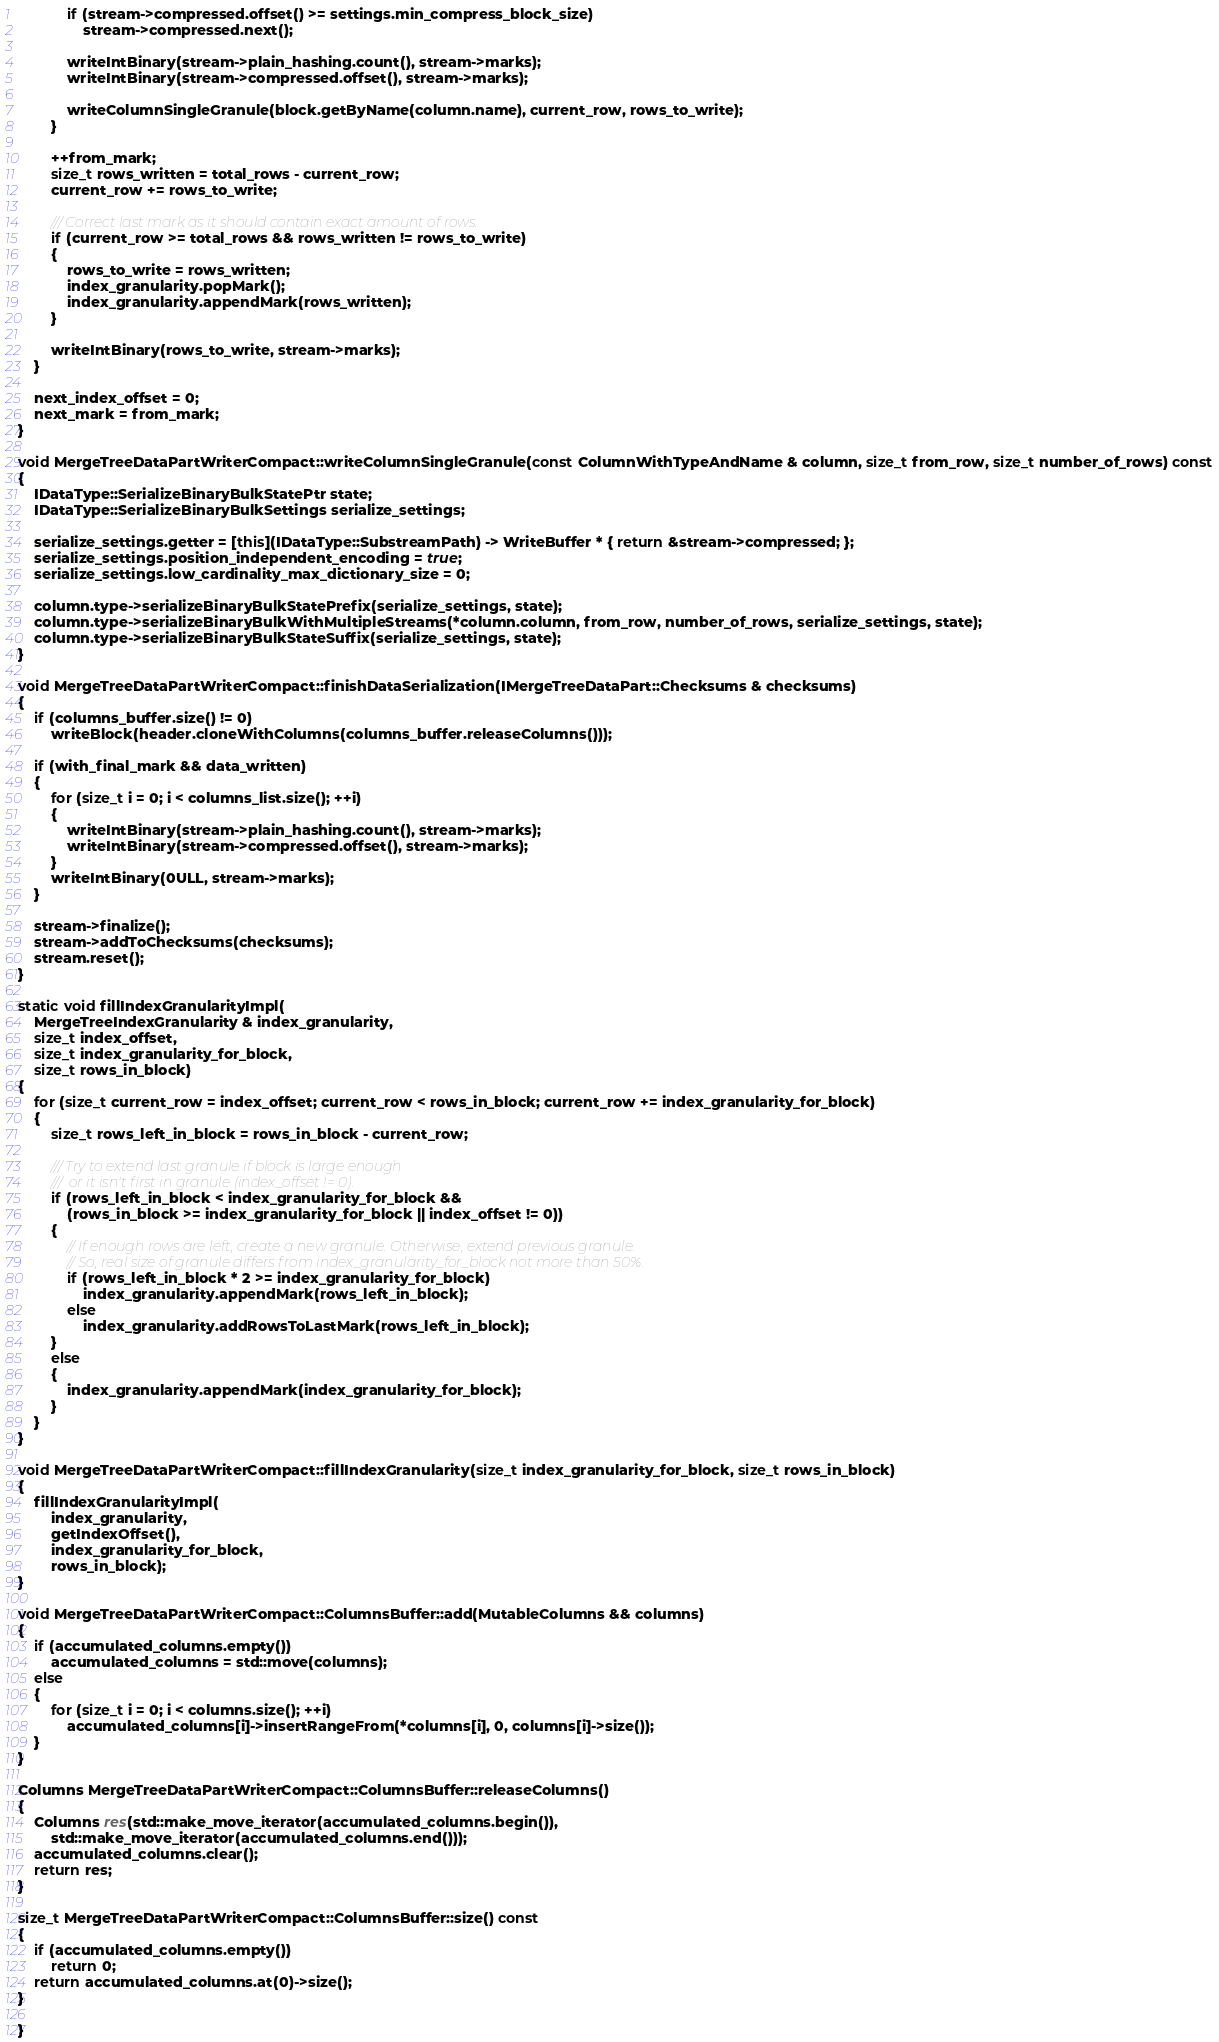<code> <loc_0><loc_0><loc_500><loc_500><_C++_>            if (stream->compressed.offset() >= settings.min_compress_block_size)
                stream->compressed.next();

            writeIntBinary(stream->plain_hashing.count(), stream->marks);
            writeIntBinary(stream->compressed.offset(), stream->marks);

            writeColumnSingleGranule(block.getByName(column.name), current_row, rows_to_write);
        }

        ++from_mark;
        size_t rows_written = total_rows - current_row;
        current_row += rows_to_write;

        /// Correct last mark as it should contain exact amount of rows.
        if (current_row >= total_rows && rows_written != rows_to_write)
        {
            rows_to_write = rows_written;
            index_granularity.popMark();
            index_granularity.appendMark(rows_written);
        }

        writeIntBinary(rows_to_write, stream->marks);
    }

    next_index_offset = 0;
    next_mark = from_mark;
}

void MergeTreeDataPartWriterCompact::writeColumnSingleGranule(const ColumnWithTypeAndName & column, size_t from_row, size_t number_of_rows) const
{
    IDataType::SerializeBinaryBulkStatePtr state;
    IDataType::SerializeBinaryBulkSettings serialize_settings;

    serialize_settings.getter = [this](IDataType::SubstreamPath) -> WriteBuffer * { return &stream->compressed; };
    serialize_settings.position_independent_encoding = true;
    serialize_settings.low_cardinality_max_dictionary_size = 0;

    column.type->serializeBinaryBulkStatePrefix(serialize_settings, state);
    column.type->serializeBinaryBulkWithMultipleStreams(*column.column, from_row, number_of_rows, serialize_settings, state);
    column.type->serializeBinaryBulkStateSuffix(serialize_settings, state);
}

void MergeTreeDataPartWriterCompact::finishDataSerialization(IMergeTreeDataPart::Checksums & checksums)
{
    if (columns_buffer.size() != 0)
        writeBlock(header.cloneWithColumns(columns_buffer.releaseColumns()));

    if (with_final_mark && data_written)
    {
        for (size_t i = 0; i < columns_list.size(); ++i)
        {
            writeIntBinary(stream->plain_hashing.count(), stream->marks);
            writeIntBinary(stream->compressed.offset(), stream->marks);
        }
        writeIntBinary(0ULL, stream->marks);
    }

    stream->finalize();
    stream->addToChecksums(checksums);
    stream.reset();
}

static void fillIndexGranularityImpl(
    MergeTreeIndexGranularity & index_granularity,
    size_t index_offset,
    size_t index_granularity_for_block,
    size_t rows_in_block)
{
    for (size_t current_row = index_offset; current_row < rows_in_block; current_row += index_granularity_for_block)
    {
        size_t rows_left_in_block = rows_in_block - current_row;

        /// Try to extend last granule if block is large enough
        ///  or it isn't first in granule (index_offset != 0).
        if (rows_left_in_block < index_granularity_for_block &&
            (rows_in_block >= index_granularity_for_block || index_offset != 0))
        {
            // If enough rows are left, create a new granule. Otherwise, extend previous granule.
            // So, real size of granule differs from index_granularity_for_block not more than 50%.
            if (rows_left_in_block * 2 >= index_granularity_for_block)
                index_granularity.appendMark(rows_left_in_block);
            else
                index_granularity.addRowsToLastMark(rows_left_in_block);
        }
        else
        {
            index_granularity.appendMark(index_granularity_for_block);
        }
    }
}

void MergeTreeDataPartWriterCompact::fillIndexGranularity(size_t index_granularity_for_block, size_t rows_in_block)
{
    fillIndexGranularityImpl(
        index_granularity,
        getIndexOffset(),
        index_granularity_for_block,
        rows_in_block);
}

void MergeTreeDataPartWriterCompact::ColumnsBuffer::add(MutableColumns && columns)
{
    if (accumulated_columns.empty())
        accumulated_columns = std::move(columns);
    else
    {
        for (size_t i = 0; i < columns.size(); ++i)
            accumulated_columns[i]->insertRangeFrom(*columns[i], 0, columns[i]->size());
    }
}

Columns MergeTreeDataPartWriterCompact::ColumnsBuffer::releaseColumns()
{
    Columns res(std::make_move_iterator(accumulated_columns.begin()),
        std::make_move_iterator(accumulated_columns.end()));
    accumulated_columns.clear();
    return res;
}

size_t MergeTreeDataPartWriterCompact::ColumnsBuffer::size() const
{
    if (accumulated_columns.empty())
        return 0;
    return accumulated_columns.at(0)->size();
}

}
</code> 